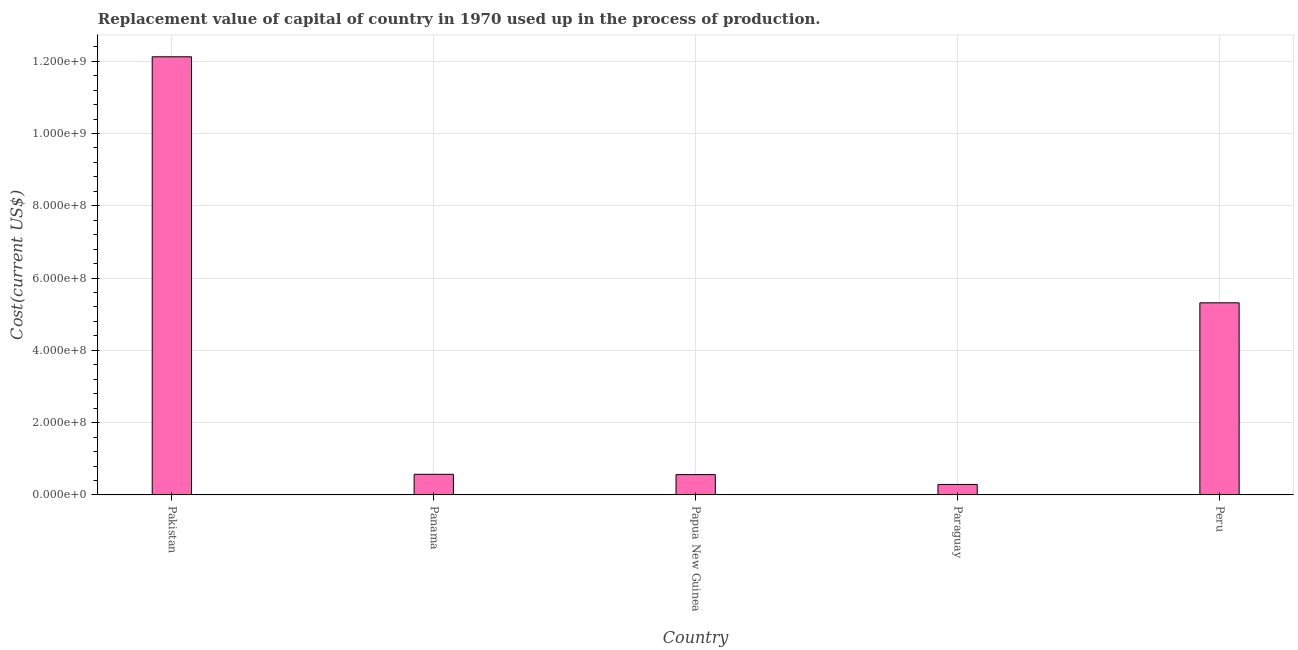What is the title of the graph?
Offer a very short reply. Replacement value of capital of country in 1970 used up in the process of production. What is the label or title of the Y-axis?
Your answer should be very brief. Cost(current US$). What is the consumption of fixed capital in Pakistan?
Provide a short and direct response. 1.21e+09. Across all countries, what is the maximum consumption of fixed capital?
Make the answer very short. 1.21e+09. Across all countries, what is the minimum consumption of fixed capital?
Your answer should be very brief. 2.90e+07. In which country was the consumption of fixed capital minimum?
Ensure brevity in your answer.  Paraguay. What is the sum of the consumption of fixed capital?
Provide a succinct answer. 1.89e+09. What is the difference between the consumption of fixed capital in Pakistan and Panama?
Your answer should be very brief. 1.16e+09. What is the average consumption of fixed capital per country?
Provide a succinct answer. 3.77e+08. What is the median consumption of fixed capital?
Keep it short and to the point. 5.71e+07. In how many countries, is the consumption of fixed capital greater than 200000000 US$?
Make the answer very short. 2. What is the ratio of the consumption of fixed capital in Pakistan to that in Paraguay?
Your answer should be compact. 41.77. Is the consumption of fixed capital in Panama less than that in Papua New Guinea?
Provide a succinct answer. No. Is the difference between the consumption of fixed capital in Pakistan and Paraguay greater than the difference between any two countries?
Offer a terse response. Yes. What is the difference between the highest and the second highest consumption of fixed capital?
Your answer should be very brief. 6.81e+08. Is the sum of the consumption of fixed capital in Papua New Guinea and Peru greater than the maximum consumption of fixed capital across all countries?
Ensure brevity in your answer.  No. What is the difference between the highest and the lowest consumption of fixed capital?
Offer a very short reply. 1.18e+09. In how many countries, is the consumption of fixed capital greater than the average consumption of fixed capital taken over all countries?
Ensure brevity in your answer.  2. How many bars are there?
Offer a terse response. 5. How many countries are there in the graph?
Provide a short and direct response. 5. What is the difference between two consecutive major ticks on the Y-axis?
Keep it short and to the point. 2.00e+08. What is the Cost(current US$) of Pakistan?
Offer a terse response. 1.21e+09. What is the Cost(current US$) of Panama?
Offer a very short reply. 5.71e+07. What is the Cost(current US$) of Papua New Guinea?
Make the answer very short. 5.62e+07. What is the Cost(current US$) of Paraguay?
Ensure brevity in your answer.  2.90e+07. What is the Cost(current US$) in Peru?
Offer a terse response. 5.31e+08. What is the difference between the Cost(current US$) in Pakistan and Panama?
Make the answer very short. 1.16e+09. What is the difference between the Cost(current US$) in Pakistan and Papua New Guinea?
Your response must be concise. 1.16e+09. What is the difference between the Cost(current US$) in Pakistan and Paraguay?
Offer a terse response. 1.18e+09. What is the difference between the Cost(current US$) in Pakistan and Peru?
Your answer should be very brief. 6.81e+08. What is the difference between the Cost(current US$) in Panama and Papua New Guinea?
Your response must be concise. 8.40e+05. What is the difference between the Cost(current US$) in Panama and Paraguay?
Keep it short and to the point. 2.80e+07. What is the difference between the Cost(current US$) in Panama and Peru?
Make the answer very short. -4.74e+08. What is the difference between the Cost(current US$) in Papua New Guinea and Paraguay?
Offer a very short reply. 2.72e+07. What is the difference between the Cost(current US$) in Papua New Guinea and Peru?
Ensure brevity in your answer.  -4.75e+08. What is the difference between the Cost(current US$) in Paraguay and Peru?
Your answer should be very brief. -5.02e+08. What is the ratio of the Cost(current US$) in Pakistan to that in Panama?
Give a very brief answer. 21.24. What is the ratio of the Cost(current US$) in Pakistan to that in Papua New Guinea?
Your answer should be very brief. 21.56. What is the ratio of the Cost(current US$) in Pakistan to that in Paraguay?
Provide a succinct answer. 41.77. What is the ratio of the Cost(current US$) in Pakistan to that in Peru?
Ensure brevity in your answer.  2.28. What is the ratio of the Cost(current US$) in Panama to that in Papua New Guinea?
Your answer should be compact. 1.01. What is the ratio of the Cost(current US$) in Panama to that in Paraguay?
Make the answer very short. 1.97. What is the ratio of the Cost(current US$) in Panama to that in Peru?
Your answer should be very brief. 0.11. What is the ratio of the Cost(current US$) in Papua New Guinea to that in Paraguay?
Keep it short and to the point. 1.94. What is the ratio of the Cost(current US$) in Papua New Guinea to that in Peru?
Ensure brevity in your answer.  0.11. What is the ratio of the Cost(current US$) in Paraguay to that in Peru?
Keep it short and to the point. 0.06. 